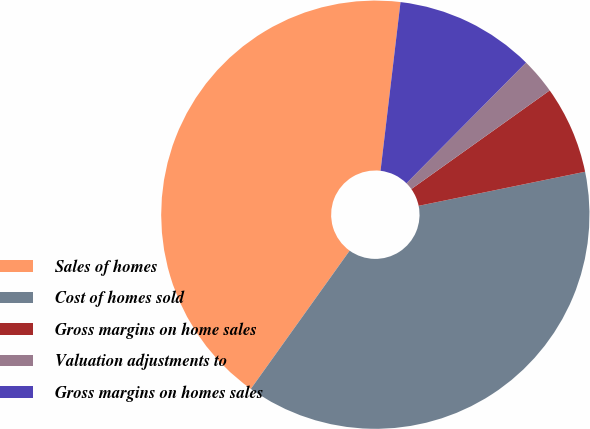<chart> <loc_0><loc_0><loc_500><loc_500><pie_chart><fcel>Sales of homes<fcel>Cost of homes sold<fcel>Gross margins on home sales<fcel>Valuation adjustments to<fcel>Gross margins on homes sales<nl><fcel>42.0%<fcel>38.09%<fcel>6.64%<fcel>2.72%<fcel>10.55%<nl></chart> 